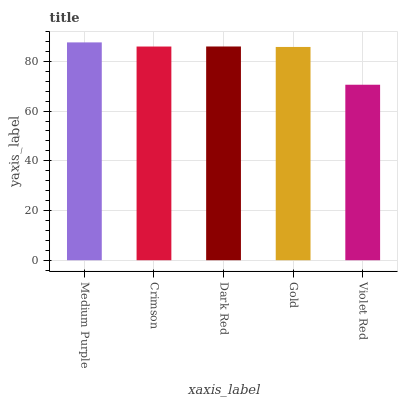Is Violet Red the minimum?
Answer yes or no. Yes. Is Medium Purple the maximum?
Answer yes or no. Yes. Is Crimson the minimum?
Answer yes or no. No. Is Crimson the maximum?
Answer yes or no. No. Is Medium Purple greater than Crimson?
Answer yes or no. Yes. Is Crimson less than Medium Purple?
Answer yes or no. Yes. Is Crimson greater than Medium Purple?
Answer yes or no. No. Is Medium Purple less than Crimson?
Answer yes or no. No. Is Crimson the high median?
Answer yes or no. Yes. Is Crimson the low median?
Answer yes or no. Yes. Is Violet Red the high median?
Answer yes or no. No. Is Medium Purple the low median?
Answer yes or no. No. 